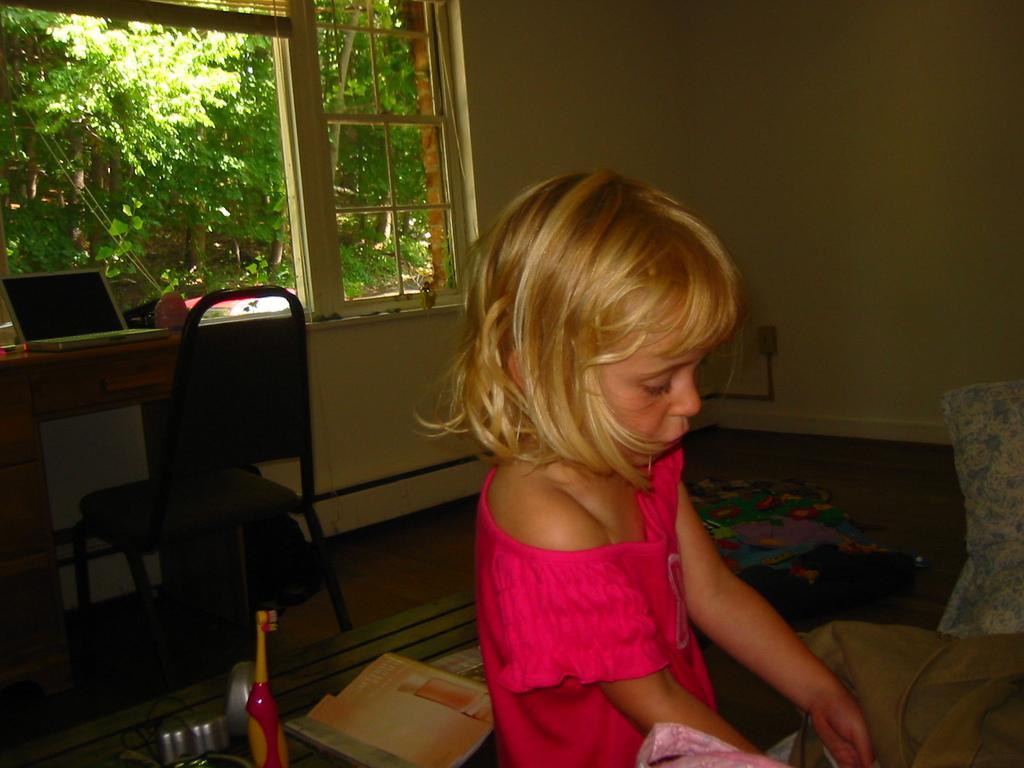Describe this image in one or two sentences. In this image I can see a girl wearing a pink color of dress. In the background I can see a chair, a laptop and number of trees. 